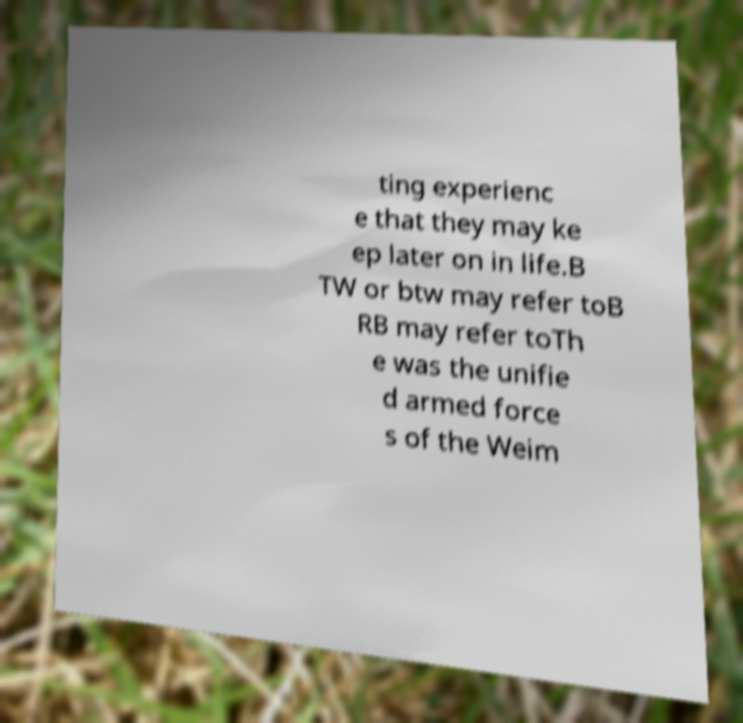Please identify and transcribe the text found in this image. ting experienc e that they may ke ep later on in life.B TW or btw may refer toB RB may refer toTh e was the unifie d armed force s of the Weim 